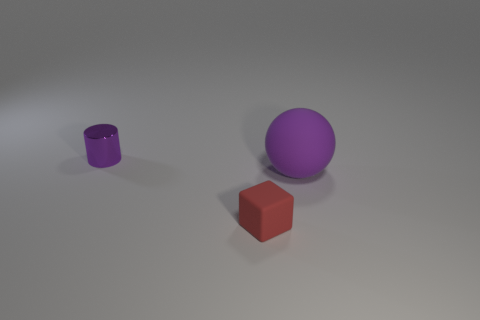What is the shape of the other large thing that is the same color as the metal thing?
Offer a terse response. Sphere. What is the color of the small thing that is in front of the small object that is behind the tiny red object that is in front of the big purple matte ball?
Your response must be concise. Red. There is a block that is the same size as the shiny cylinder; what color is it?
Make the answer very short. Red. Does the metallic cylinder have the same color as the rubber object right of the red cube?
Ensure brevity in your answer.  Yes. What material is the thing that is left of the tiny object on the right side of the tiny shiny cylinder?
Offer a very short reply. Metal. How many objects are both in front of the big thing and behind the large purple matte sphere?
Keep it short and to the point. 0. What number of other objects are there of the same size as the red matte thing?
Ensure brevity in your answer.  1. Does the object behind the large purple sphere have the same shape as the purple thing in front of the purple shiny cylinder?
Provide a succinct answer. No. Are there any things to the left of the tiny matte thing?
Your response must be concise. Yes. Are there any other things that are the same shape as the red rubber object?
Make the answer very short. No. 